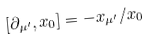Convert formula to latex. <formula><loc_0><loc_0><loc_500><loc_500>[ \partial _ { \mu ^ { \prime } } , x _ { 0 } ] = - x _ { \mu ^ { \prime } } / x _ { 0 }</formula> 